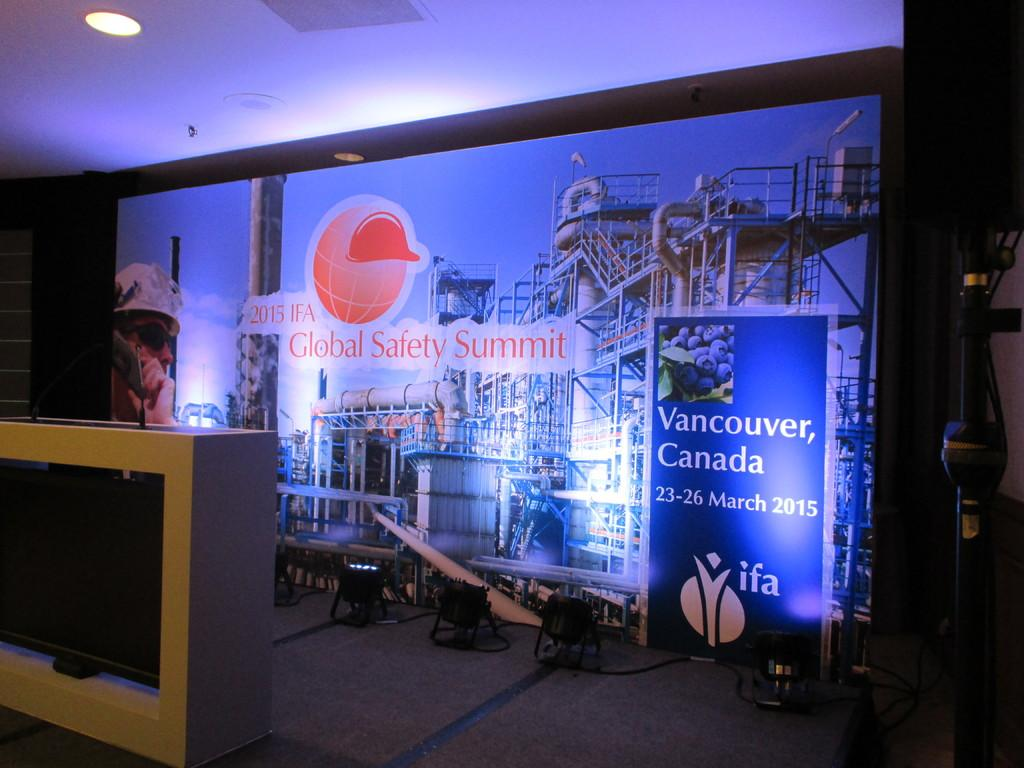<image>
Describe the image concisely. A sign introducing the 2015 IFA Global Safety Summit in Vancouver, Canada 